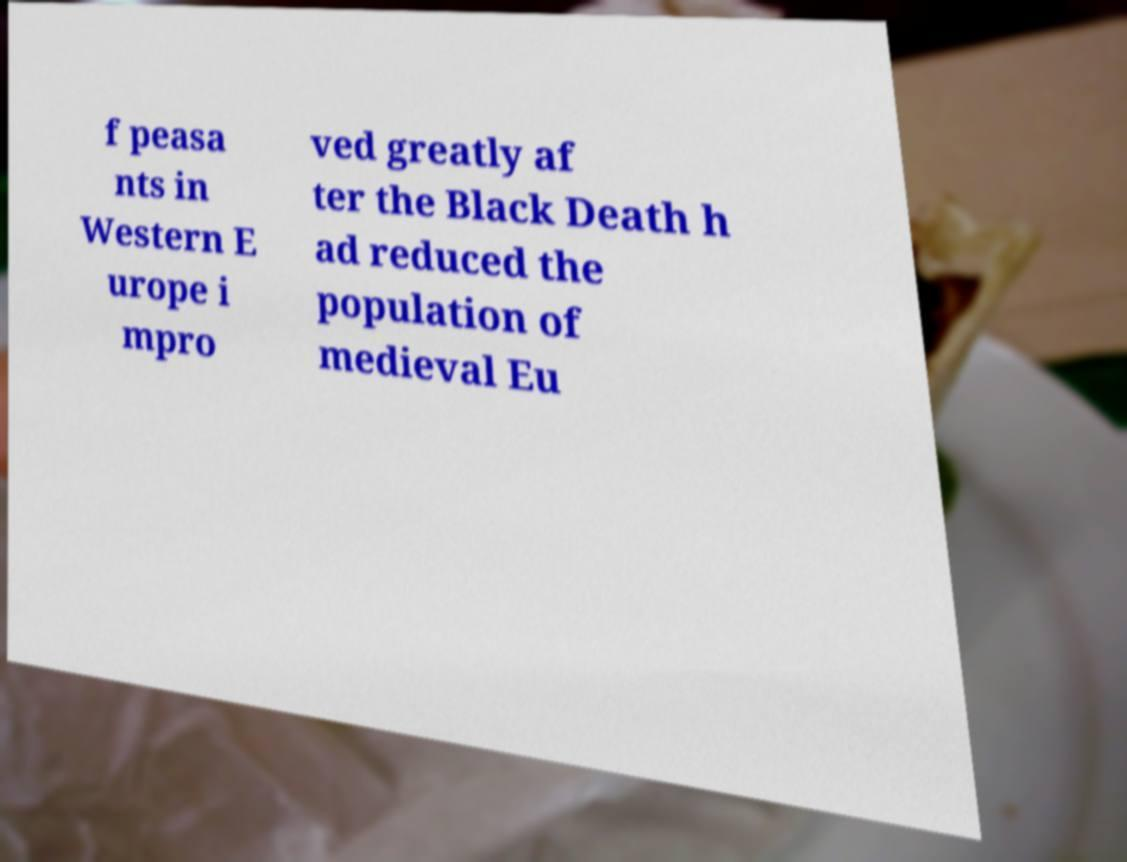There's text embedded in this image that I need extracted. Can you transcribe it verbatim? f peasa nts in Western E urope i mpro ved greatly af ter the Black Death h ad reduced the population of medieval Eu 